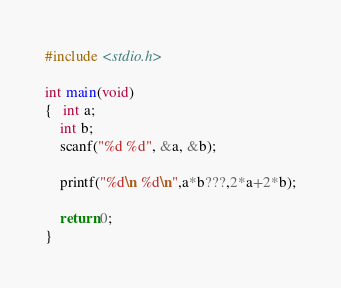Convert code to text. <code><loc_0><loc_0><loc_500><loc_500><_C_>#include <stdio.h>
  
int main(void)
{   int a;
    int b;
    scanf("%d %d", &a, &b);
 
    printf("%d\n %d\n",a*b???,2*a+2*b);
 
    return 0;
} </code> 